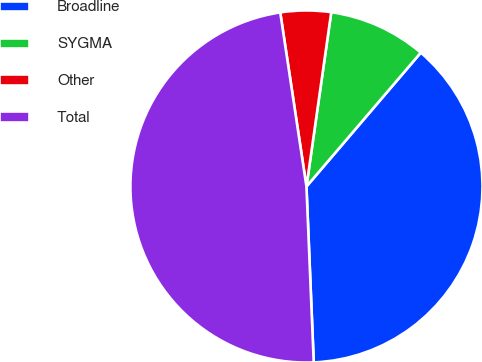Convert chart to OTSL. <chart><loc_0><loc_0><loc_500><loc_500><pie_chart><fcel>Broadline<fcel>SYGMA<fcel>Other<fcel>Total<nl><fcel>38.09%<fcel>9.0%<fcel>4.63%<fcel>48.28%<nl></chart> 